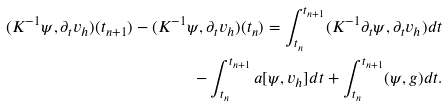Convert formula to latex. <formula><loc_0><loc_0><loc_500><loc_500>( K ^ { - 1 } \psi , \partial _ { t } v _ { h } ) ( t _ { n + 1 } ) - ( K ^ { - 1 } \psi , \partial _ { t } v _ { h } ) ( t _ { n } ) = \int _ { t _ { n } } ^ { t _ { n + 1 } } ( K ^ { - 1 } \partial _ { t } \psi , \partial _ { t } v _ { h } ) d t \\ - \int _ { t _ { n } } ^ { t _ { n + 1 } } a [ \psi , v _ { h } ] d t + \int _ { t _ { n } } ^ { t _ { n + 1 } } ( \psi , g ) d t .</formula> 